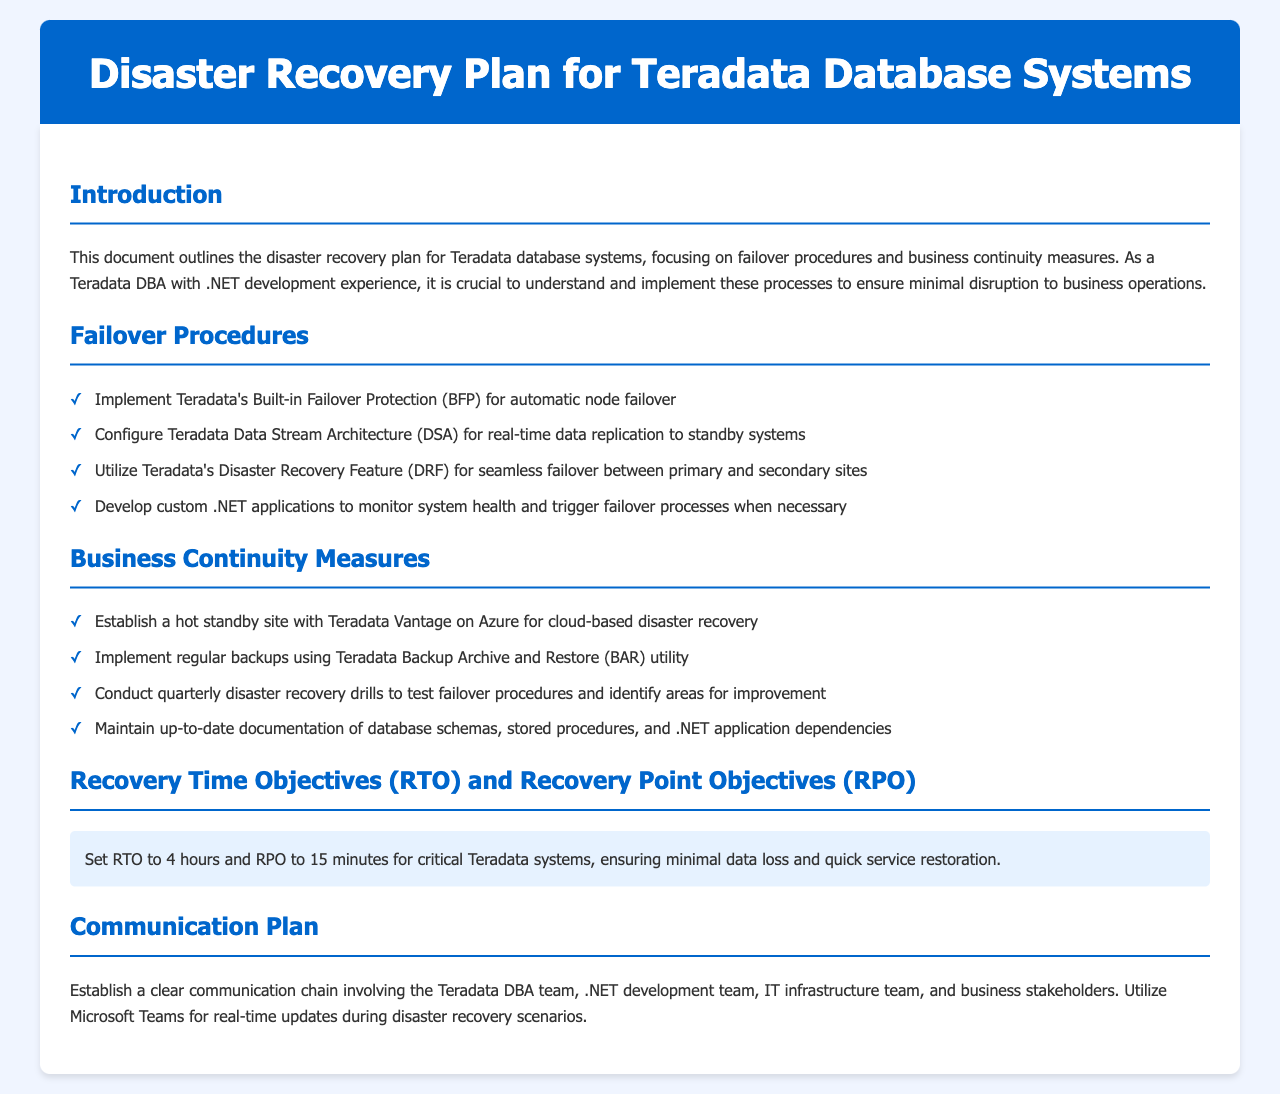What is the recovery time objective (RTO)? The document states the RTO is set to ensure minimal data loss and quick service restoration for critical Teradata systems.
Answer: 4 hours What is the recovery point objective (RPO)? The RPO is specified in the document as a target to minimize data loss for critical Teradata systems.
Answer: 15 minutes What utility is used for regular backups? The document specifies the utility that should be implemented for regular backups within the disaster recovery plan.
Answer: Teradata Backup Archive and Restore (BAR) How often should disaster recovery drills be conducted? The policy recommends a frequency for conducting drills to test failover procedures.
Answer: Quarterly What communication tool should be used for updates during disaster recovery? The document states a specific tool used for real-time updates concerning disaster recovery scenarios.
Answer: Microsoft Teams What type of site should be established for disaster recovery? The document specifies the kind of site that should be set up for effective disaster recovery measures.
Answer: Hot standby site What feature is utilized for seamless failover? The document includes a specific feature to facilitate smooth failover between sites.
Answer: Teradata's Disaster Recovery Feature (DRF) Which architecture is configured for real-time data replication? The policy document mentions an architecture that supports real-time data replication to standby systems.
Answer: Teradata Data Stream Architecture (DSA) 